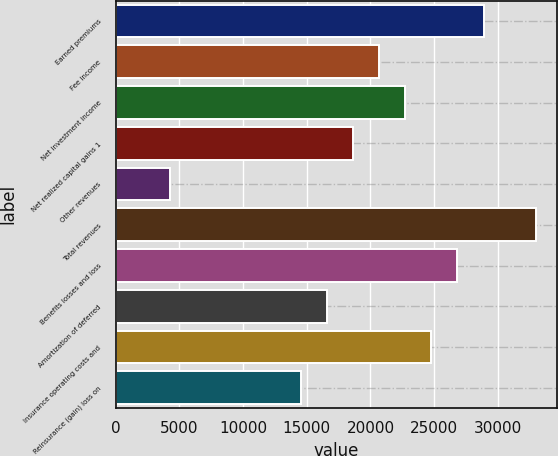Convert chart. <chart><loc_0><loc_0><loc_500><loc_500><bar_chart><fcel>Earned premiums<fcel>Fee income<fcel>Net investment income<fcel>Net realized capital gains 1<fcel>Other revenues<fcel>Total revenues<fcel>Benefits losses and loss<fcel>Amortization of deferred<fcel>Insurance operating costs and<fcel>Reinsurance (gain) loss on<nl><fcel>28871.8<fcel>20673<fcel>22722.7<fcel>18623.3<fcel>4275.4<fcel>32971.2<fcel>26822.1<fcel>16573.6<fcel>24772.4<fcel>14523.9<nl></chart> 